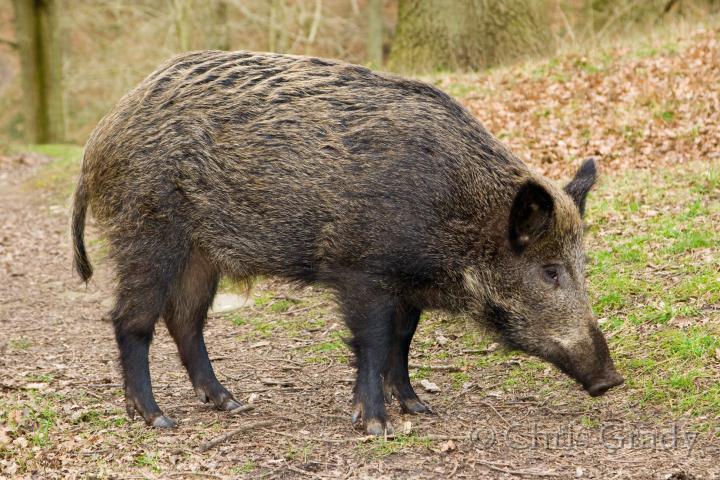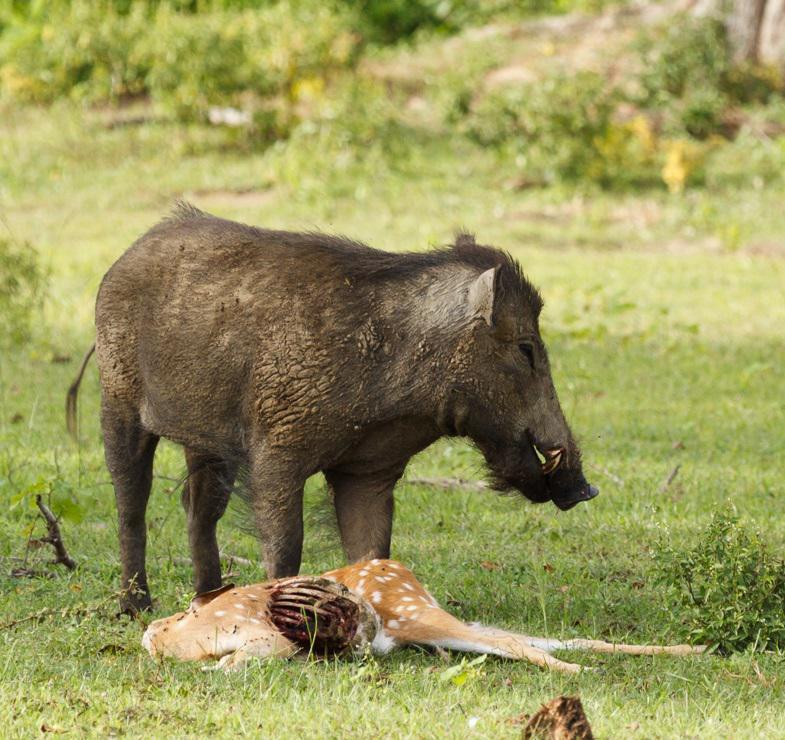The first image is the image on the left, the second image is the image on the right. Examine the images to the left and right. Is the description "There is more than one warthog in one of these images." accurate? Answer yes or no. No. 